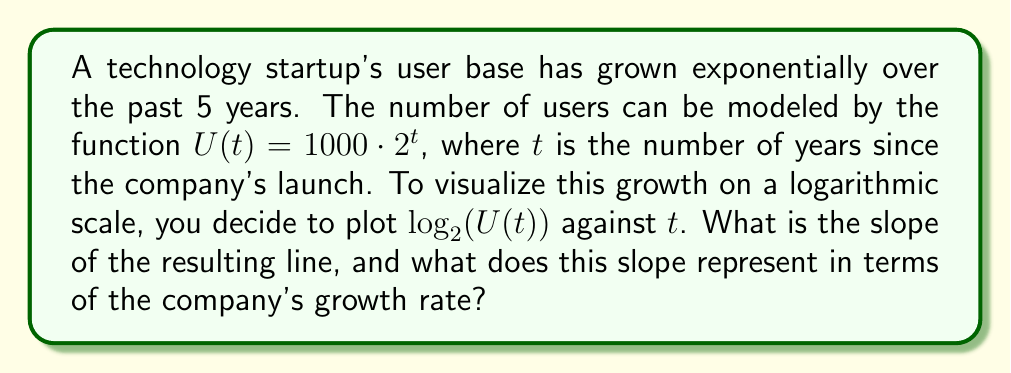Show me your answer to this math problem. Let's approach this step-by-step:

1) First, we need to express $\log_2(U(t))$ in terms of $t$:

   $\log_2(U(t)) = \log_2(1000 \cdot 2^t)$

2) Using the logarithm property $\log_a(xy) = \log_a(x) + \log_a(y)$, we get:

   $\log_2(U(t)) = \log_2(1000) + \log_2(2^t)$

3) Using the property $\log_a(a^x) = x$, we simplify:

   $\log_2(U(t)) = \log_2(1000) + t$

4) $\log_2(1000)$ is a constant. Let's call it $c$. So we have:

   $\log_2(U(t)) = c + t$

5) This is a linear equation in the form $y = mx + b$, where:
   - $y$ is $\log_2(U(t))$
   - $x$ is $t$
   - $m$ (the slope) is 1
   - $b$ (the y-intercept) is $c$

6) Therefore, the slope of the line is 1.

7) In terms of growth rate, a slope of 1 on a log-2 scale means that the value doubles every unit of $t$ (every year in this case).

   This is because $2^1 = 2$, so each increment of 1 in the $y$ direction ($\log_2$ scale) corresponds to doubling in the original scale.
Answer: Slope: 1; Represents doubling of users annually 